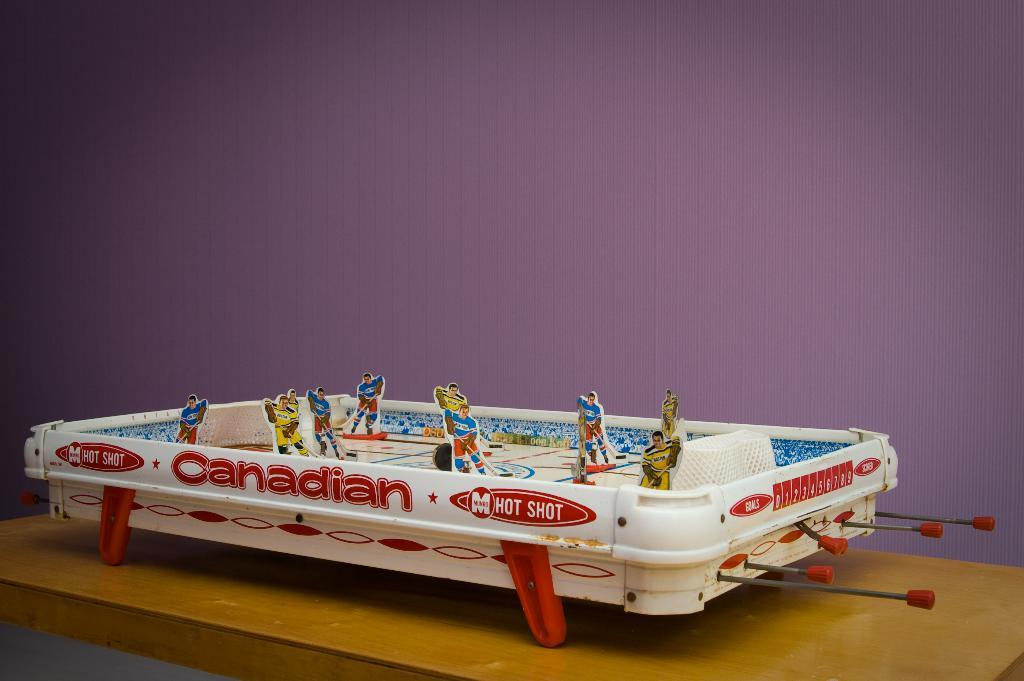What type of object is the main subject of the image? There is a toy game in the image. What colors are used for the toy game? The toy game is white and red in color. On what surface is the toy game placed? The toy game is on a brown-colored table. What can be seen in the background of the image? The background of the image includes a wall. What color is the wall in the image? The wall is purple in color. How many loaves of bread are on the table next to the toy game? There is no loaf of bread present in the image; the toy game is on a brown-colored table with no visible loaves of bread. 